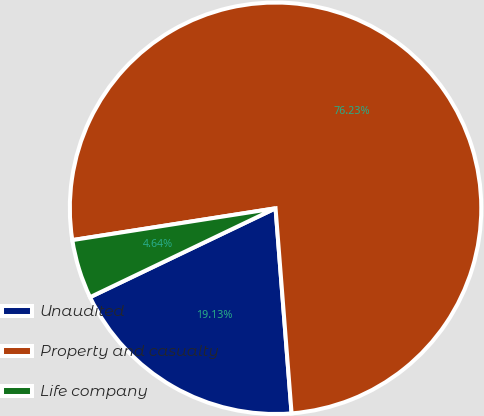Convert chart to OTSL. <chart><loc_0><loc_0><loc_500><loc_500><pie_chart><fcel>Unaudited<fcel>Property and casualty<fcel>Life company<nl><fcel>19.13%<fcel>76.23%<fcel>4.64%<nl></chart> 